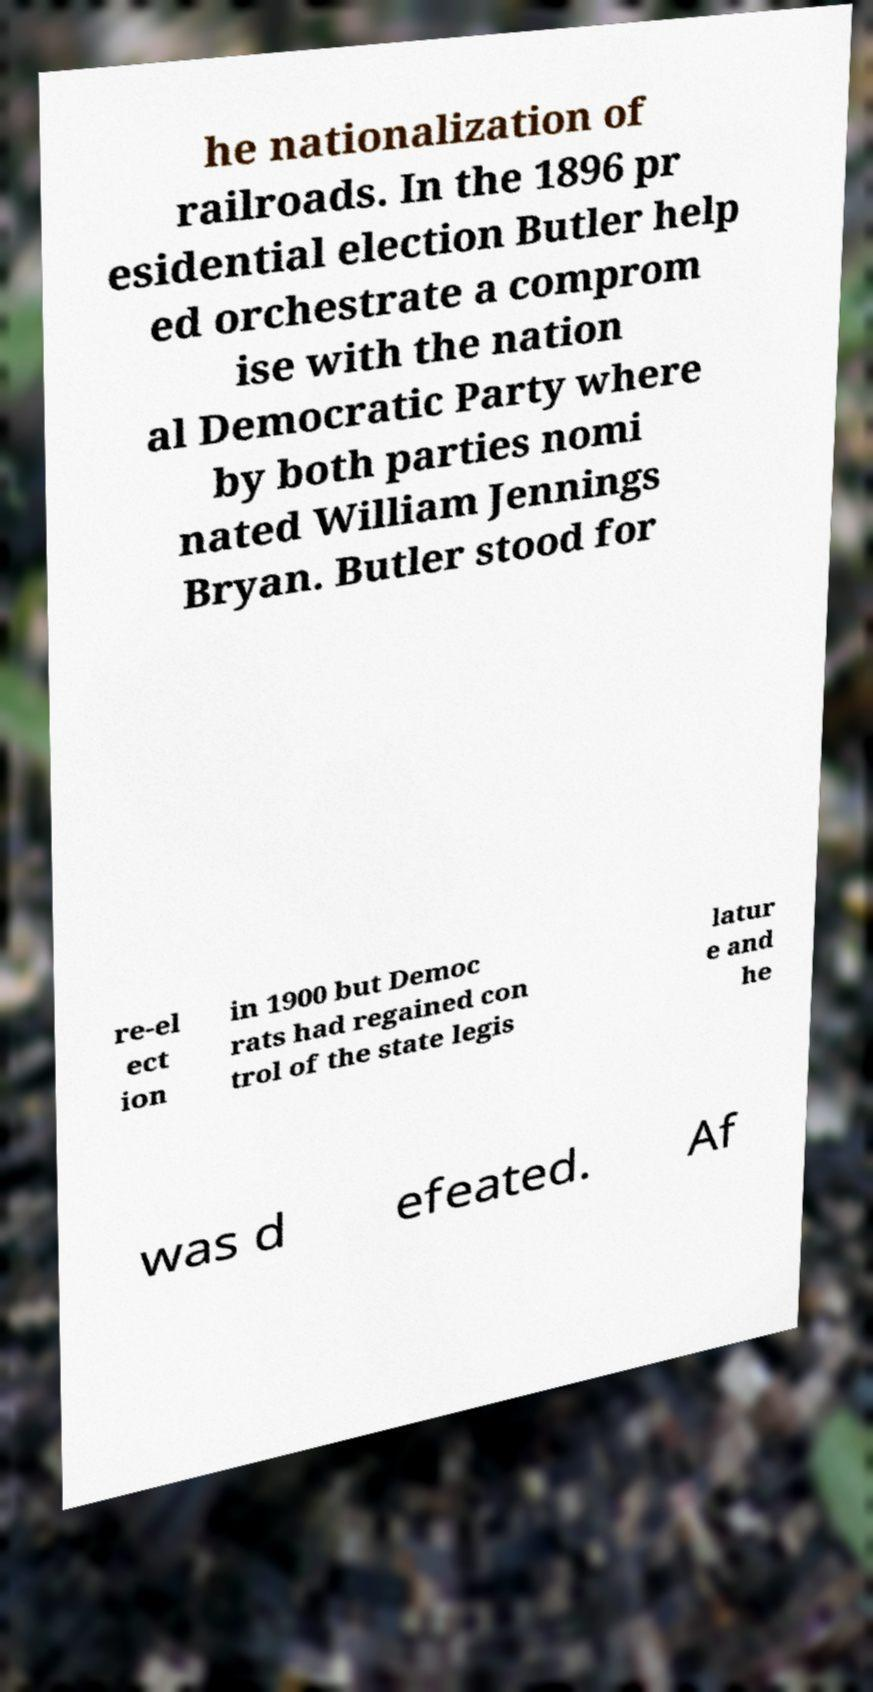Could you assist in decoding the text presented in this image and type it out clearly? he nationalization of railroads. In the 1896 pr esidential election Butler help ed orchestrate a comprom ise with the nation al Democratic Party where by both parties nomi nated William Jennings Bryan. Butler stood for re-el ect ion in 1900 but Democ rats had regained con trol of the state legis latur e and he was d efeated. Af 